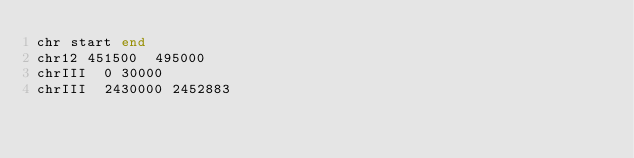Convert code to text. <code><loc_0><loc_0><loc_500><loc_500><_SQL_>chr	start	end
chr12	451500	495000
chrIII	0	30000
chrIII	2430000	2452883
</code> 